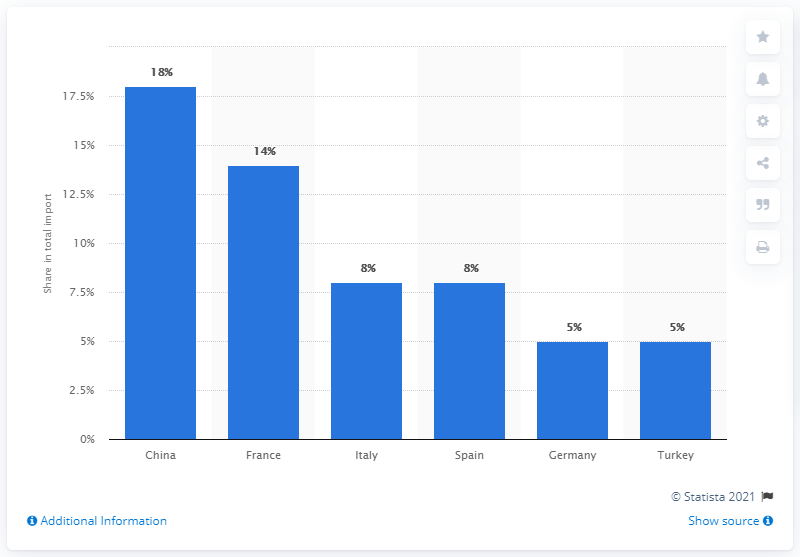Draw attention to some important aspects in this diagram. In 2019, Algeria's most important import partner was China. 